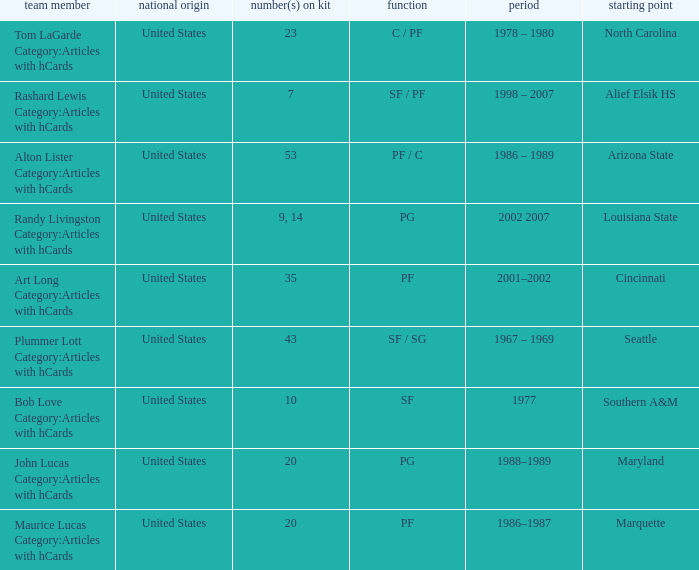Which number(s) appeared on tom lagarde's jersey in articles that included hcards? 23.0. 